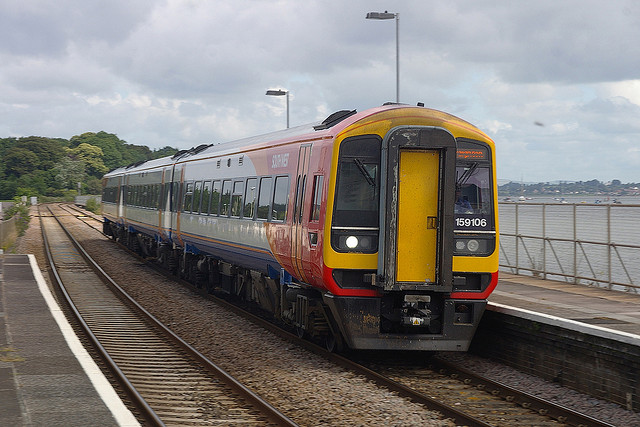Please identify all text content in this image. 159106 